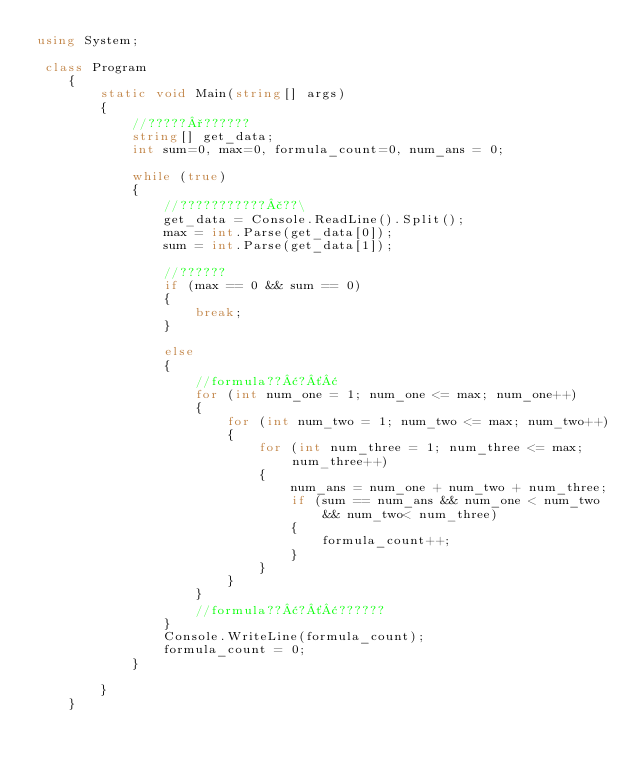Convert code to text. <code><loc_0><loc_0><loc_500><loc_500><_C#_>using System;

 class Program
    {
        static void Main(string[] args)
        {
            //?????°??????
            string[] get_data;
            int sum=0, max=0, formula_count=0, num_ans = 0;

            while (true)
            {
                //???????????£??\
                get_data = Console.ReadLine().Split();
                max = int.Parse(get_data[0]);
                sum = int.Parse(get_data[1]);

                //??????
                if (max == 0 && sum == 0)
                {
                    break;
                }

                else
                {
                    //formula??¢?´¢
                    for (int num_one = 1; num_one <= max; num_one++)
                    {
                        for (int num_two = 1; num_two <= max; num_two++)
                        {
                            for (int num_three = 1; num_three <= max; num_three++)
                            {
                                num_ans = num_one + num_two + num_three;
                                if (sum == num_ans && num_one < num_two && num_two< num_three)
                                {
                                    formula_count++;
                                }
                            }
                        }
                    }
                    //formula??¢?´¢??????
                }
                Console.WriteLine(formula_count);
                formula_count = 0;
            }

        }
    }</code> 